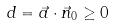Convert formula to latex. <formula><loc_0><loc_0><loc_500><loc_500>d = \vec { a } \cdot \vec { n } _ { 0 } \geq 0</formula> 